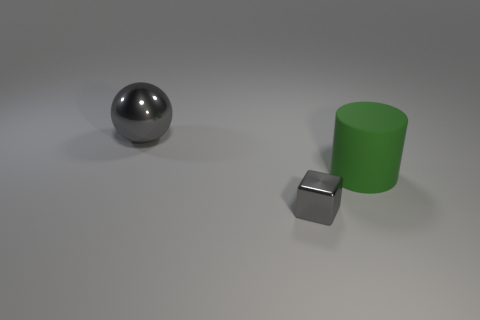Is there anything else that is the same size as the gray block?
Keep it short and to the point. No. There is a thing that is both to the left of the green rubber cylinder and to the right of the big metallic thing; what material is it?
Provide a succinct answer. Metal. Are there any green cylinders that are behind the gray thing that is in front of the cylinder?
Offer a terse response. Yes. What number of large metal spheres have the same color as the cylinder?
Offer a very short reply. 0. There is a big object that is the same color as the small cube; what is its material?
Offer a terse response. Metal. Do the tiny gray object and the large green thing have the same material?
Offer a very short reply. No. Are there any gray things to the left of the gray cube?
Provide a succinct answer. Yes. There is a gray thing on the right side of the big object behind the cylinder; what is it made of?
Keep it short and to the point. Metal. Do the matte cylinder and the large shiny sphere have the same color?
Offer a very short reply. No. The object that is both in front of the large gray object and behind the tiny gray object is what color?
Your response must be concise. Green. 